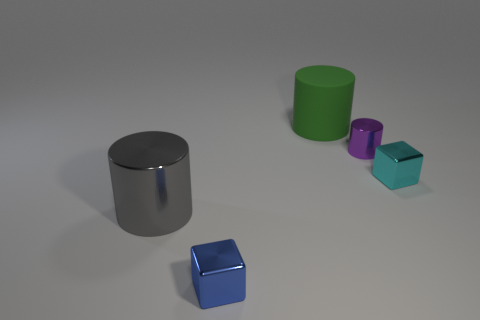Is there anything else that is the same material as the big green thing?
Offer a terse response. No. What is the color of the small object that is the same shape as the big metal thing?
Provide a short and direct response. Purple. What size is the blue shiny block?
Keep it short and to the point. Small. What number of other cylinders are the same size as the purple cylinder?
Offer a terse response. 0. Are the tiny block that is behind the big gray metallic cylinder and the gray object in front of the purple thing made of the same material?
Provide a short and direct response. Yes. Are there more gray objects than tiny gray metal cubes?
Give a very brief answer. Yes. Is there any other thing that is the same color as the matte thing?
Offer a terse response. No. Do the tiny cylinder and the cyan cube have the same material?
Your response must be concise. Yes. Are there fewer green matte things than shiny cylinders?
Provide a succinct answer. Yes. Does the cyan thing have the same shape as the small blue thing?
Your answer should be very brief. Yes. 